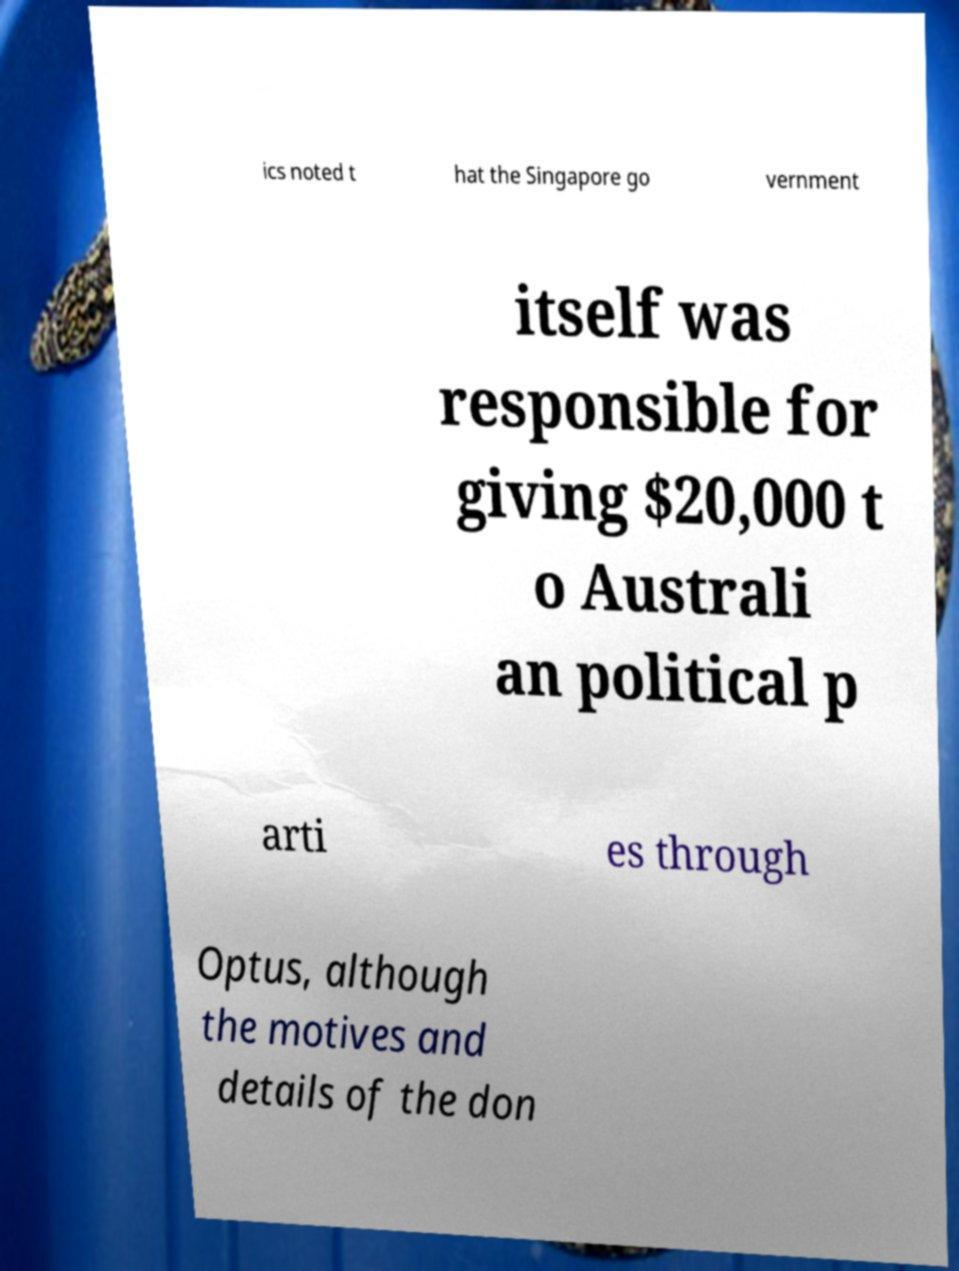I need the written content from this picture converted into text. Can you do that? ics noted t hat the Singapore go vernment itself was responsible for giving $20,000 t o Australi an political p arti es through Optus, although the motives and details of the don 